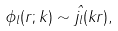<formula> <loc_0><loc_0><loc_500><loc_500>\phi _ { l } ( r ; k ) \sim \hat { j _ { l } } ( k r ) ,</formula> 